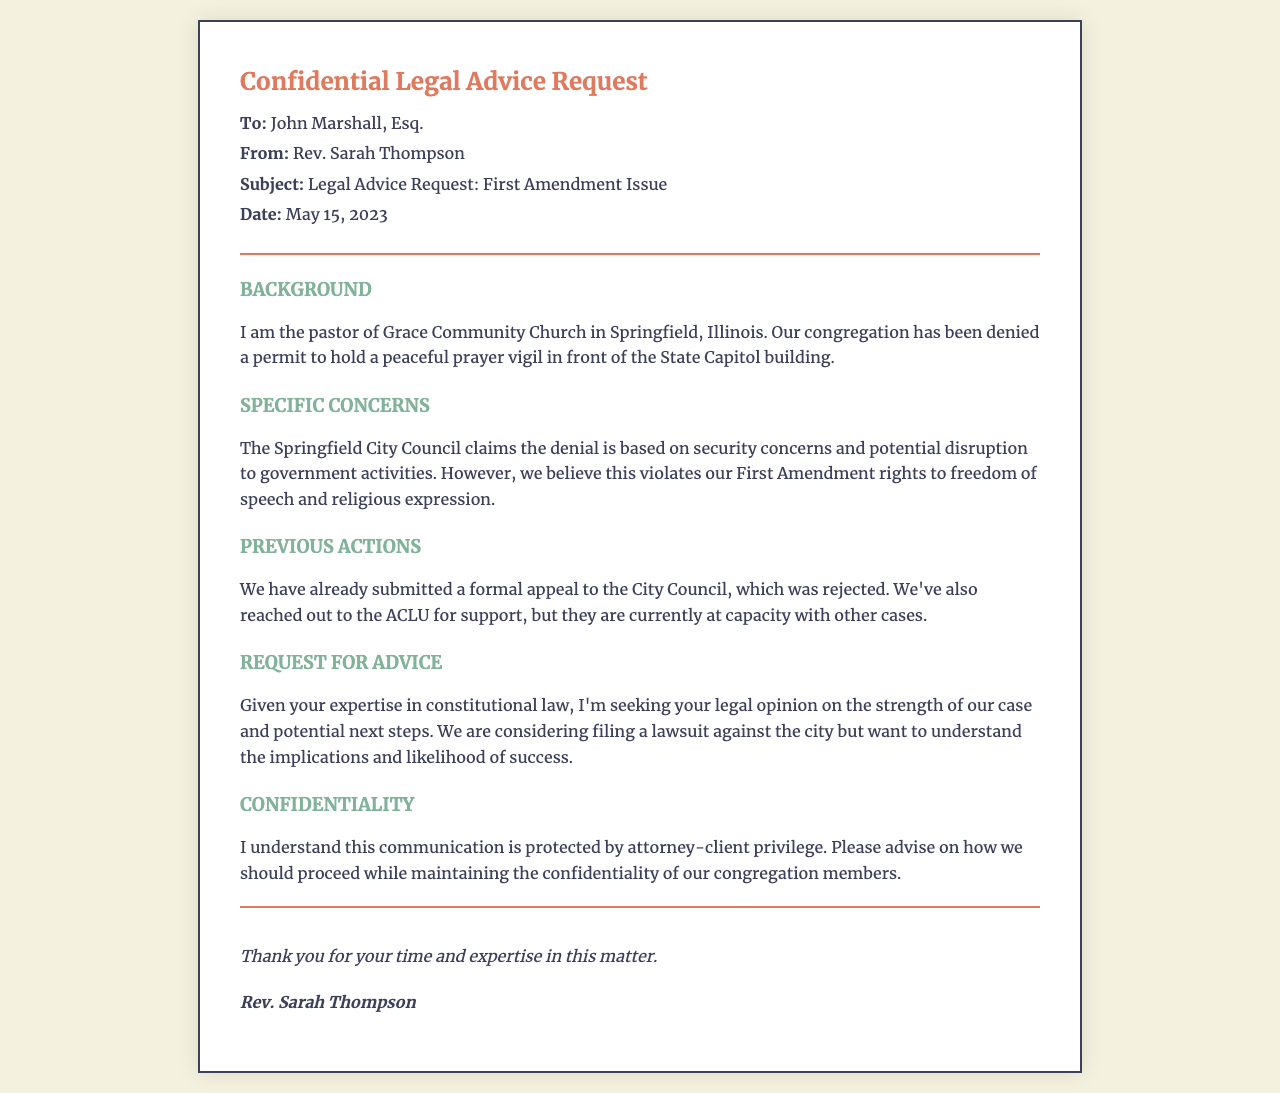What is the name of the sender? The name of the sender is found in the 'From' section of the document.
Answer: Rev. Sarah Thompson Who is the recipient of the fax? The recipient is listed in the 'To' section of the document.
Answer: John Marshall, Esq What is the date of the communication? The date is provided in the header of the document.
Answer: May 15, 2023 What is the location of Grace Community Church? The location is mentioned in the background section of the document.
Answer: Springfield, Illinois What is the main issue discussed in the document? The main issue revolves around the denial of a permit to hold a prayer vigil, as detailed in the background section.
Answer: Denial of a permit What previous action was taken regarding the permit? The document states that a formal appeal was submitted to the City Council.
Answer: Formal appeal submitted What organization was contacted for support? The name of the organization reached out to for help is mentioned in the 'Previous Actions' section.
Answer: ACLU What legal issue is the sender concerned about? The specific legal concern is stated in the 'Specific Concerns' section.
Answer: First Amendment rights What does the sender want to know regarding the case? The sender is seeking information about the strength of their case and potential next steps, mentioned in the 'Request for Advice' section.
Answer: Strength of the case What is the sender's stance on the city's justification for denying the permit? The sender believes the justification violates their rights, as outlined in the specific concerns section.
Answer: Violates First Amendment rights 